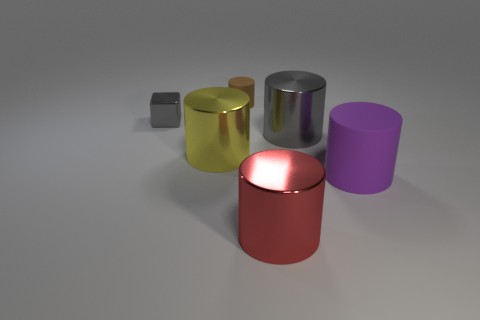Subtract 1 cylinders. How many cylinders are left? 4 Subtract all gray cylinders. How many cylinders are left? 4 Subtract all big gray metallic cylinders. How many cylinders are left? 4 Subtract all blue cylinders. Subtract all purple cubes. How many cylinders are left? 5 Add 1 yellow cylinders. How many objects exist? 7 Subtract all blocks. How many objects are left? 5 Subtract all tiny brown things. Subtract all gray metal cylinders. How many objects are left? 4 Add 2 red metal cylinders. How many red metal cylinders are left? 3 Add 6 big yellow matte things. How many big yellow matte things exist? 6 Subtract 1 gray cylinders. How many objects are left? 5 